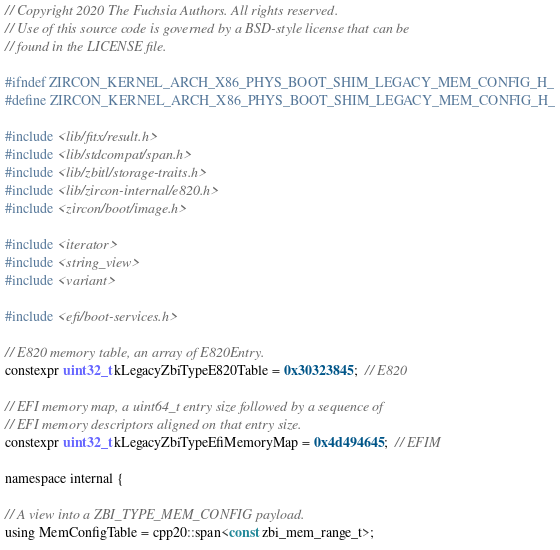<code> <loc_0><loc_0><loc_500><loc_500><_C_>// Copyright 2020 The Fuchsia Authors. All rights reserved.
// Use of this source code is governed by a BSD-style license that can be
// found in the LICENSE file.

#ifndef ZIRCON_KERNEL_ARCH_X86_PHYS_BOOT_SHIM_LEGACY_MEM_CONFIG_H_
#define ZIRCON_KERNEL_ARCH_X86_PHYS_BOOT_SHIM_LEGACY_MEM_CONFIG_H_

#include <lib/fitx/result.h>
#include <lib/stdcompat/span.h>
#include <lib/zbitl/storage-traits.h>
#include <lib/zircon-internal/e820.h>
#include <zircon/boot/image.h>

#include <iterator>
#include <string_view>
#include <variant>

#include <efi/boot-services.h>

// E820 memory table, an array of E820Entry.
constexpr uint32_t kLegacyZbiTypeE820Table = 0x30323845;  // E820

// EFI memory map, a uint64_t entry size followed by a sequence of
// EFI memory descriptors aligned on that entry size.
constexpr uint32_t kLegacyZbiTypeEfiMemoryMap = 0x4d494645;  // EFIM

namespace internal {

// A view into a ZBI_TYPE_MEM_CONFIG payload.
using MemConfigTable = cpp20::span<const zbi_mem_range_t>;
</code> 